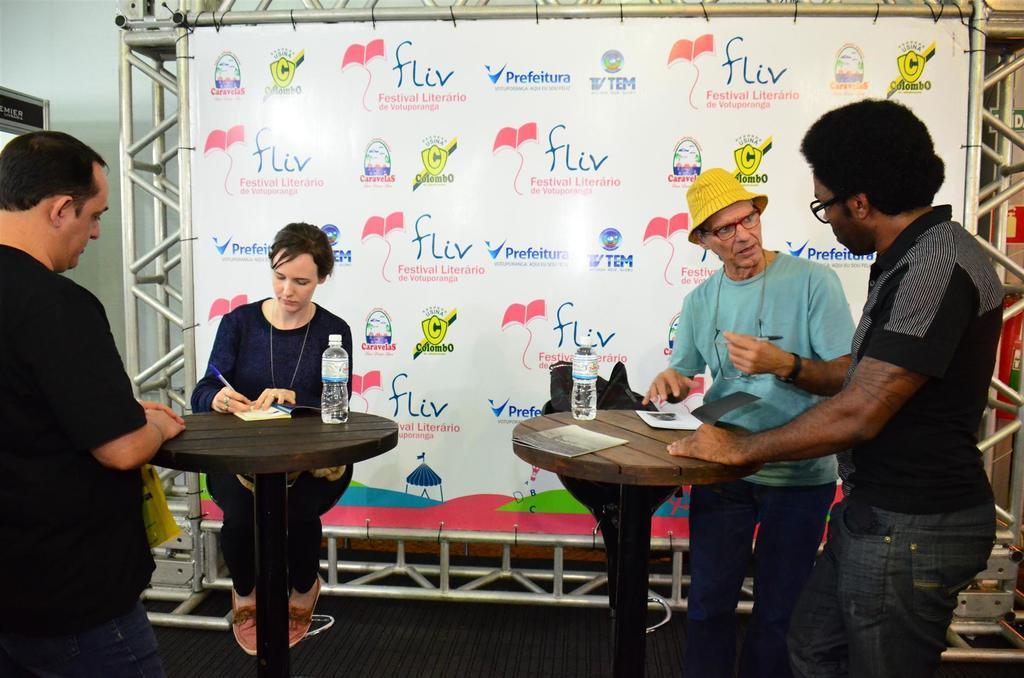In one or two sentences, can you explain what this image depicts? In this image there are two tables, chairs. There are four people in this image one woman and three men. 2 men are standing to the right side one man is standing to the left side, woman is to the left side, woman is wearing blue color shirt and black color pant two men are wearing black color t-shirt and one man is wearing blue color t-shirt with a hat, there is a banner backside of them. 